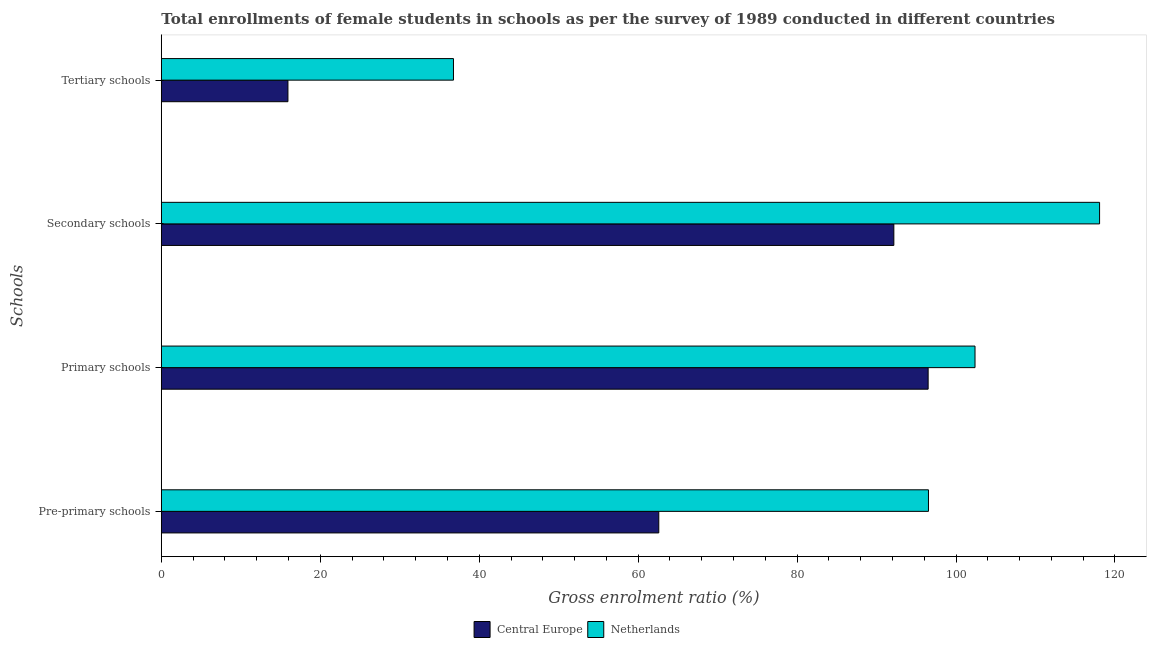How many different coloured bars are there?
Keep it short and to the point. 2. How many groups of bars are there?
Your response must be concise. 4. Are the number of bars per tick equal to the number of legend labels?
Your response must be concise. Yes. What is the label of the 4th group of bars from the top?
Your answer should be very brief. Pre-primary schools. What is the gross enrolment ratio(female) in tertiary schools in Central Europe?
Give a very brief answer. 15.93. Across all countries, what is the maximum gross enrolment ratio(female) in tertiary schools?
Keep it short and to the point. 36.76. Across all countries, what is the minimum gross enrolment ratio(female) in secondary schools?
Provide a short and direct response. 92.17. In which country was the gross enrolment ratio(female) in secondary schools maximum?
Ensure brevity in your answer.  Netherlands. In which country was the gross enrolment ratio(female) in tertiary schools minimum?
Offer a terse response. Central Europe. What is the total gross enrolment ratio(female) in primary schools in the graph?
Ensure brevity in your answer.  198.88. What is the difference between the gross enrolment ratio(female) in tertiary schools in Central Europe and that in Netherlands?
Offer a terse response. -20.83. What is the difference between the gross enrolment ratio(female) in tertiary schools in Netherlands and the gross enrolment ratio(female) in secondary schools in Central Europe?
Your response must be concise. -55.41. What is the average gross enrolment ratio(female) in secondary schools per country?
Your answer should be very brief. 105.12. What is the difference between the gross enrolment ratio(female) in tertiary schools and gross enrolment ratio(female) in secondary schools in Central Europe?
Your answer should be very brief. -76.24. What is the ratio of the gross enrolment ratio(female) in secondary schools in Netherlands to that in Central Europe?
Make the answer very short. 1.28. Is the gross enrolment ratio(female) in secondary schools in Netherlands less than that in Central Europe?
Offer a very short reply. No. Is the difference between the gross enrolment ratio(female) in secondary schools in Netherlands and Central Europe greater than the difference between the gross enrolment ratio(female) in tertiary schools in Netherlands and Central Europe?
Your answer should be very brief. Yes. What is the difference between the highest and the second highest gross enrolment ratio(female) in tertiary schools?
Your response must be concise. 20.83. What is the difference between the highest and the lowest gross enrolment ratio(female) in tertiary schools?
Offer a terse response. 20.83. Is the sum of the gross enrolment ratio(female) in tertiary schools in Central Europe and Netherlands greater than the maximum gross enrolment ratio(female) in pre-primary schools across all countries?
Offer a very short reply. No. Is it the case that in every country, the sum of the gross enrolment ratio(female) in primary schools and gross enrolment ratio(female) in secondary schools is greater than the sum of gross enrolment ratio(female) in pre-primary schools and gross enrolment ratio(female) in tertiary schools?
Your response must be concise. Yes. What does the 2nd bar from the top in Primary schools represents?
Your answer should be compact. Central Europe. Is it the case that in every country, the sum of the gross enrolment ratio(female) in pre-primary schools and gross enrolment ratio(female) in primary schools is greater than the gross enrolment ratio(female) in secondary schools?
Give a very brief answer. Yes. How many bars are there?
Keep it short and to the point. 8. Are all the bars in the graph horizontal?
Your answer should be compact. Yes. How many countries are there in the graph?
Offer a very short reply. 2. What is the difference between two consecutive major ticks on the X-axis?
Your answer should be compact. 20. Are the values on the major ticks of X-axis written in scientific E-notation?
Provide a succinct answer. No. Does the graph contain any zero values?
Ensure brevity in your answer.  No. Does the graph contain grids?
Keep it short and to the point. No. How many legend labels are there?
Offer a terse response. 2. How are the legend labels stacked?
Your answer should be compact. Horizontal. What is the title of the graph?
Provide a short and direct response. Total enrollments of female students in schools as per the survey of 1989 conducted in different countries. What is the label or title of the X-axis?
Keep it short and to the point. Gross enrolment ratio (%). What is the label or title of the Y-axis?
Give a very brief answer. Schools. What is the Gross enrolment ratio (%) in Central Europe in Pre-primary schools?
Make the answer very short. 62.6. What is the Gross enrolment ratio (%) in Netherlands in Pre-primary schools?
Your answer should be compact. 96.53. What is the Gross enrolment ratio (%) of Central Europe in Primary schools?
Give a very brief answer. 96.49. What is the Gross enrolment ratio (%) in Netherlands in Primary schools?
Provide a succinct answer. 102.39. What is the Gross enrolment ratio (%) of Central Europe in Secondary schools?
Provide a short and direct response. 92.17. What is the Gross enrolment ratio (%) in Netherlands in Secondary schools?
Ensure brevity in your answer.  118.06. What is the Gross enrolment ratio (%) of Central Europe in Tertiary schools?
Your answer should be compact. 15.93. What is the Gross enrolment ratio (%) in Netherlands in Tertiary schools?
Provide a short and direct response. 36.76. Across all Schools, what is the maximum Gross enrolment ratio (%) of Central Europe?
Your response must be concise. 96.49. Across all Schools, what is the maximum Gross enrolment ratio (%) of Netherlands?
Your answer should be very brief. 118.06. Across all Schools, what is the minimum Gross enrolment ratio (%) of Central Europe?
Provide a succinct answer. 15.93. Across all Schools, what is the minimum Gross enrolment ratio (%) in Netherlands?
Your answer should be compact. 36.76. What is the total Gross enrolment ratio (%) of Central Europe in the graph?
Make the answer very short. 267.19. What is the total Gross enrolment ratio (%) in Netherlands in the graph?
Offer a very short reply. 353.74. What is the difference between the Gross enrolment ratio (%) in Central Europe in Pre-primary schools and that in Primary schools?
Make the answer very short. -33.89. What is the difference between the Gross enrolment ratio (%) in Netherlands in Pre-primary schools and that in Primary schools?
Keep it short and to the point. -5.86. What is the difference between the Gross enrolment ratio (%) of Central Europe in Pre-primary schools and that in Secondary schools?
Offer a very short reply. -29.58. What is the difference between the Gross enrolment ratio (%) in Netherlands in Pre-primary schools and that in Secondary schools?
Provide a succinct answer. -21.53. What is the difference between the Gross enrolment ratio (%) of Central Europe in Pre-primary schools and that in Tertiary schools?
Your response must be concise. 46.66. What is the difference between the Gross enrolment ratio (%) of Netherlands in Pre-primary schools and that in Tertiary schools?
Your answer should be very brief. 59.77. What is the difference between the Gross enrolment ratio (%) in Central Europe in Primary schools and that in Secondary schools?
Offer a very short reply. 4.31. What is the difference between the Gross enrolment ratio (%) in Netherlands in Primary schools and that in Secondary schools?
Ensure brevity in your answer.  -15.67. What is the difference between the Gross enrolment ratio (%) of Central Europe in Primary schools and that in Tertiary schools?
Your response must be concise. 80.56. What is the difference between the Gross enrolment ratio (%) of Netherlands in Primary schools and that in Tertiary schools?
Ensure brevity in your answer.  65.63. What is the difference between the Gross enrolment ratio (%) of Central Europe in Secondary schools and that in Tertiary schools?
Provide a succinct answer. 76.24. What is the difference between the Gross enrolment ratio (%) in Netherlands in Secondary schools and that in Tertiary schools?
Your response must be concise. 81.3. What is the difference between the Gross enrolment ratio (%) of Central Europe in Pre-primary schools and the Gross enrolment ratio (%) of Netherlands in Primary schools?
Your answer should be compact. -39.79. What is the difference between the Gross enrolment ratio (%) in Central Europe in Pre-primary schools and the Gross enrolment ratio (%) in Netherlands in Secondary schools?
Provide a succinct answer. -55.47. What is the difference between the Gross enrolment ratio (%) in Central Europe in Pre-primary schools and the Gross enrolment ratio (%) in Netherlands in Tertiary schools?
Keep it short and to the point. 25.83. What is the difference between the Gross enrolment ratio (%) of Central Europe in Primary schools and the Gross enrolment ratio (%) of Netherlands in Secondary schools?
Offer a very short reply. -21.57. What is the difference between the Gross enrolment ratio (%) of Central Europe in Primary schools and the Gross enrolment ratio (%) of Netherlands in Tertiary schools?
Offer a very short reply. 59.73. What is the difference between the Gross enrolment ratio (%) in Central Europe in Secondary schools and the Gross enrolment ratio (%) in Netherlands in Tertiary schools?
Your answer should be compact. 55.41. What is the average Gross enrolment ratio (%) in Central Europe per Schools?
Provide a short and direct response. 66.8. What is the average Gross enrolment ratio (%) in Netherlands per Schools?
Make the answer very short. 88.44. What is the difference between the Gross enrolment ratio (%) of Central Europe and Gross enrolment ratio (%) of Netherlands in Pre-primary schools?
Make the answer very short. -33.94. What is the difference between the Gross enrolment ratio (%) of Central Europe and Gross enrolment ratio (%) of Netherlands in Primary schools?
Provide a short and direct response. -5.9. What is the difference between the Gross enrolment ratio (%) in Central Europe and Gross enrolment ratio (%) in Netherlands in Secondary schools?
Offer a very short reply. -25.89. What is the difference between the Gross enrolment ratio (%) of Central Europe and Gross enrolment ratio (%) of Netherlands in Tertiary schools?
Provide a succinct answer. -20.83. What is the ratio of the Gross enrolment ratio (%) of Central Europe in Pre-primary schools to that in Primary schools?
Keep it short and to the point. 0.65. What is the ratio of the Gross enrolment ratio (%) in Netherlands in Pre-primary schools to that in Primary schools?
Give a very brief answer. 0.94. What is the ratio of the Gross enrolment ratio (%) in Central Europe in Pre-primary schools to that in Secondary schools?
Provide a succinct answer. 0.68. What is the ratio of the Gross enrolment ratio (%) of Netherlands in Pre-primary schools to that in Secondary schools?
Provide a short and direct response. 0.82. What is the ratio of the Gross enrolment ratio (%) of Central Europe in Pre-primary schools to that in Tertiary schools?
Offer a very short reply. 3.93. What is the ratio of the Gross enrolment ratio (%) of Netherlands in Pre-primary schools to that in Tertiary schools?
Your answer should be compact. 2.63. What is the ratio of the Gross enrolment ratio (%) in Central Europe in Primary schools to that in Secondary schools?
Your answer should be very brief. 1.05. What is the ratio of the Gross enrolment ratio (%) in Netherlands in Primary schools to that in Secondary schools?
Ensure brevity in your answer.  0.87. What is the ratio of the Gross enrolment ratio (%) of Central Europe in Primary schools to that in Tertiary schools?
Your response must be concise. 6.06. What is the ratio of the Gross enrolment ratio (%) of Netherlands in Primary schools to that in Tertiary schools?
Give a very brief answer. 2.79. What is the ratio of the Gross enrolment ratio (%) of Central Europe in Secondary schools to that in Tertiary schools?
Provide a short and direct response. 5.79. What is the ratio of the Gross enrolment ratio (%) of Netherlands in Secondary schools to that in Tertiary schools?
Give a very brief answer. 3.21. What is the difference between the highest and the second highest Gross enrolment ratio (%) in Central Europe?
Keep it short and to the point. 4.31. What is the difference between the highest and the second highest Gross enrolment ratio (%) of Netherlands?
Provide a short and direct response. 15.67. What is the difference between the highest and the lowest Gross enrolment ratio (%) of Central Europe?
Offer a terse response. 80.56. What is the difference between the highest and the lowest Gross enrolment ratio (%) in Netherlands?
Ensure brevity in your answer.  81.3. 